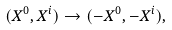Convert formula to latex. <formula><loc_0><loc_0><loc_500><loc_500>( X ^ { 0 } , X ^ { i } ) \rightarrow ( - X ^ { 0 } , - X ^ { i } ) ,</formula> 